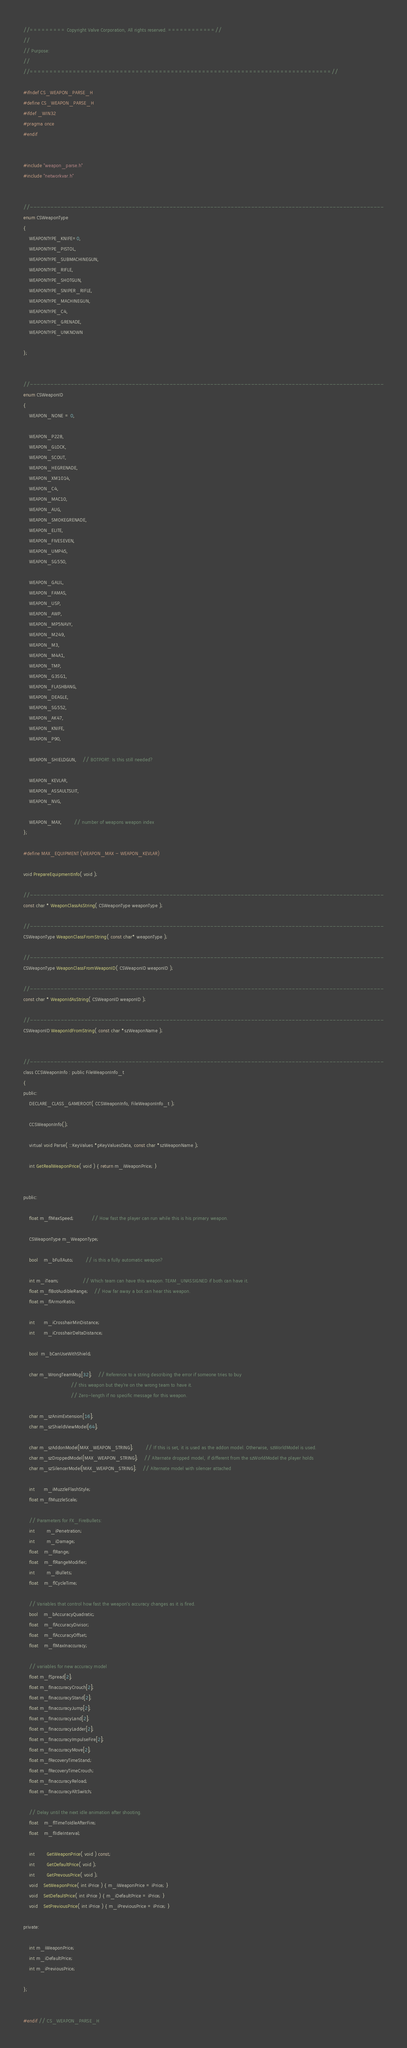<code> <loc_0><loc_0><loc_500><loc_500><_C_>//========= Copyright Valve Corporation, All rights reserved. ============//
//
// Purpose: 
//
//=============================================================================//

#ifndef CS_WEAPON_PARSE_H
#define CS_WEAPON_PARSE_H
#ifdef _WIN32
#pragma once
#endif


#include "weapon_parse.h"
#include "networkvar.h"


//--------------------------------------------------------------------------------------------------------
enum CSWeaponType
{
	WEAPONTYPE_KNIFE=0,	
	WEAPONTYPE_PISTOL,
	WEAPONTYPE_SUBMACHINEGUN,
	WEAPONTYPE_RIFLE,
	WEAPONTYPE_SHOTGUN,
	WEAPONTYPE_SNIPER_RIFLE,
	WEAPONTYPE_MACHINEGUN,
	WEAPONTYPE_C4,
	WEAPONTYPE_GRENADE,
	WEAPONTYPE_UNKNOWN

};


//--------------------------------------------------------------------------------------------------------
enum CSWeaponID
{
	WEAPON_NONE = 0,

	WEAPON_P228,
	WEAPON_GLOCK,
	WEAPON_SCOUT,
	WEAPON_HEGRENADE,
	WEAPON_XM1014,
	WEAPON_C4,
	WEAPON_MAC10,
	WEAPON_AUG,
	WEAPON_SMOKEGRENADE,
	WEAPON_ELITE,
	WEAPON_FIVESEVEN,
	WEAPON_UMP45,
	WEAPON_SG550,

	WEAPON_GALIL,
	WEAPON_FAMAS,
	WEAPON_USP,
	WEAPON_AWP,
	WEAPON_MP5NAVY,
	WEAPON_M249,
	WEAPON_M3,
	WEAPON_M4A1,
	WEAPON_TMP,
	WEAPON_G3SG1,
	WEAPON_FLASHBANG,
	WEAPON_DEAGLE,
	WEAPON_SG552,
	WEAPON_AK47,
	WEAPON_KNIFE,
	WEAPON_P90,

	WEAPON_SHIELDGUN,	// BOTPORT: Is this still needed?

	WEAPON_KEVLAR,
	WEAPON_ASSAULTSUIT,
	WEAPON_NVG,

	WEAPON_MAX,		// number of weapons weapon index
};

#define MAX_EQUIPMENT (WEAPON_MAX - WEAPON_KEVLAR)

void PrepareEquipmentInfo( void );

//--------------------------------------------------------------------------------------------------------
const char * WeaponClassAsString( CSWeaponType weaponType );

//--------------------------------------------------------------------------------------------------------
CSWeaponType WeaponClassFromString( const char* weaponType );

//--------------------------------------------------------------------------------------------------------
CSWeaponType WeaponClassFromWeaponID( CSWeaponID weaponID );

//--------------------------------------------------------------------------------------------------------
const char * WeaponIdAsString( CSWeaponID weaponID );

//--------------------------------------------------------------------------------------------------------
CSWeaponID WeaponIdFromString( const char *szWeaponName );


//--------------------------------------------------------------------------------------------------------
class CCSWeaponInfo : public FileWeaponInfo_t
{
public:
	DECLARE_CLASS_GAMEROOT( CCSWeaponInfo, FileWeaponInfo_t );
	
	CCSWeaponInfo();
	
	virtual void Parse( ::KeyValues *pKeyValuesData, const char *szWeaponName );

	int GetRealWeaponPrice( void ) { return m_iWeaponPrice; }


public:

	float m_flMaxSpeed;			// How fast the player can run while this is his primary weapon.

	CSWeaponType m_WeaponType;

	bool	m_bFullAuto;		// is this a fully automatic weapon?

	int m_iTeam;				// Which team can have this weapon. TEAM_UNASSIGNED if both can have it.
	float m_flBotAudibleRange;	// How far away a bot can hear this weapon.
	float m_flArmorRatio;

	int	  m_iCrosshairMinDistance;
	int	  m_iCrosshairDeltaDistance;
	
	bool  m_bCanUseWithShield;
	
	char m_WrongTeamMsg[32];	// Reference to a string describing the error if someone tries to buy
								// this weapon but they're on the wrong team to have it.
								// Zero-length if no specific message for this weapon.

	char m_szAnimExtension[16];
	char m_szShieldViewModel[64];

	char m_szAddonModel[MAX_WEAPON_STRING];		// If this is set, it is used as the addon model. Otherwise, szWorldModel is used.
	char m_szDroppedModel[MAX_WEAPON_STRING];	// Alternate dropped model, if different from the szWorldModel the player holds
	char m_szSilencerModel[MAX_WEAPON_STRING];	// Alternate model with silencer attached

	int	  m_iMuzzleFlashStyle;
	float m_flMuzzleScale;
	
	// Parameters for FX_FireBullets:
	int		m_iPenetration;
	int		m_iDamage;
	float	m_flRange;
	float	m_flRangeModifier;
	int		m_iBullets;
	float	m_flCycleTime;

	// Variables that control how fast the weapon's accuracy changes as it is fired.
	bool	m_bAccuracyQuadratic;
	float	m_flAccuracyDivisor;
	float	m_flAccuracyOffset;
	float	m_flMaxInaccuracy;

	// variables for new accuracy model
	float m_fSpread[2];
	float m_fInaccuracyCrouch[2];
	float m_fInaccuracyStand[2];
	float m_fInaccuracyJump[2];
	float m_fInaccuracyLand[2];
	float m_fInaccuracyLadder[2];
	float m_fInaccuracyImpulseFire[2];
	float m_fInaccuracyMove[2];
	float m_fRecoveryTimeStand;
	float m_fRecoveryTimeCrouch;
	float m_fInaccuracyReload;
	float m_fInaccuracyAltSwitch;

	// Delay until the next idle animation after shooting.
	float	m_flTimeToIdleAfterFire;
	float	m_flIdleInterval;
   
	int		GetWeaponPrice( void ) const;
	int		GetDefaultPrice( void );
	int		GetPrevousPrice( void );
	void	SetWeaponPrice( int iPrice ) { m_iWeaponPrice = iPrice; }
	void	SetDefaultPrice( int iPrice ) { m_iDefaultPrice = iPrice; }
	void	SetPreviousPrice( int iPrice ) { m_iPreviousPrice = iPrice; }
    
private:

	int m_iWeaponPrice;
	int m_iDefaultPrice;
	int m_iPreviousPrice;

};


#endif // CS_WEAPON_PARSE_H
</code> 